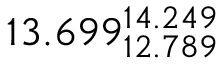Convert formula to latex. <formula><loc_0><loc_0><loc_500><loc_500>1 3 . 6 9 9 _ { 1 2 . 7 8 9 } ^ { 1 4 . 2 4 9 }</formula> 